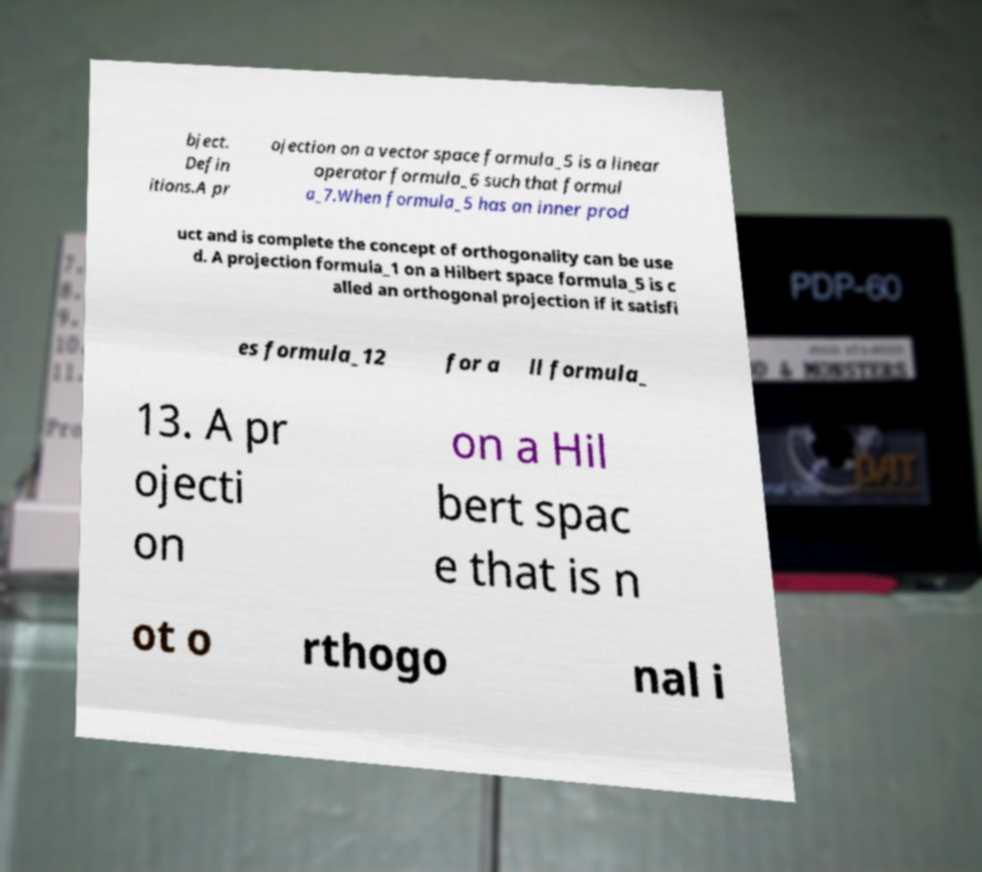Can you accurately transcribe the text from the provided image for me? bject. Defin itions.A pr ojection on a vector space formula_5 is a linear operator formula_6 such that formul a_7.When formula_5 has an inner prod uct and is complete the concept of orthogonality can be use d. A projection formula_1 on a Hilbert space formula_5 is c alled an orthogonal projection if it satisfi es formula_12 for a ll formula_ 13. A pr ojecti on on a Hil bert spac e that is n ot o rthogo nal i 